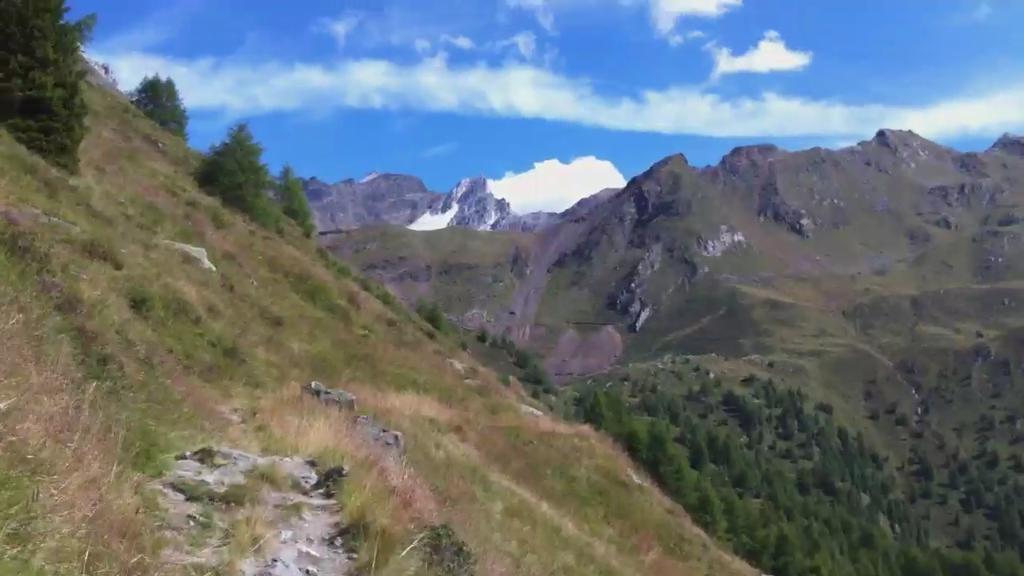Describe this image in one or two sentences. In the picture I can see trees, the grass and mountains. In the background I can see the sky. 